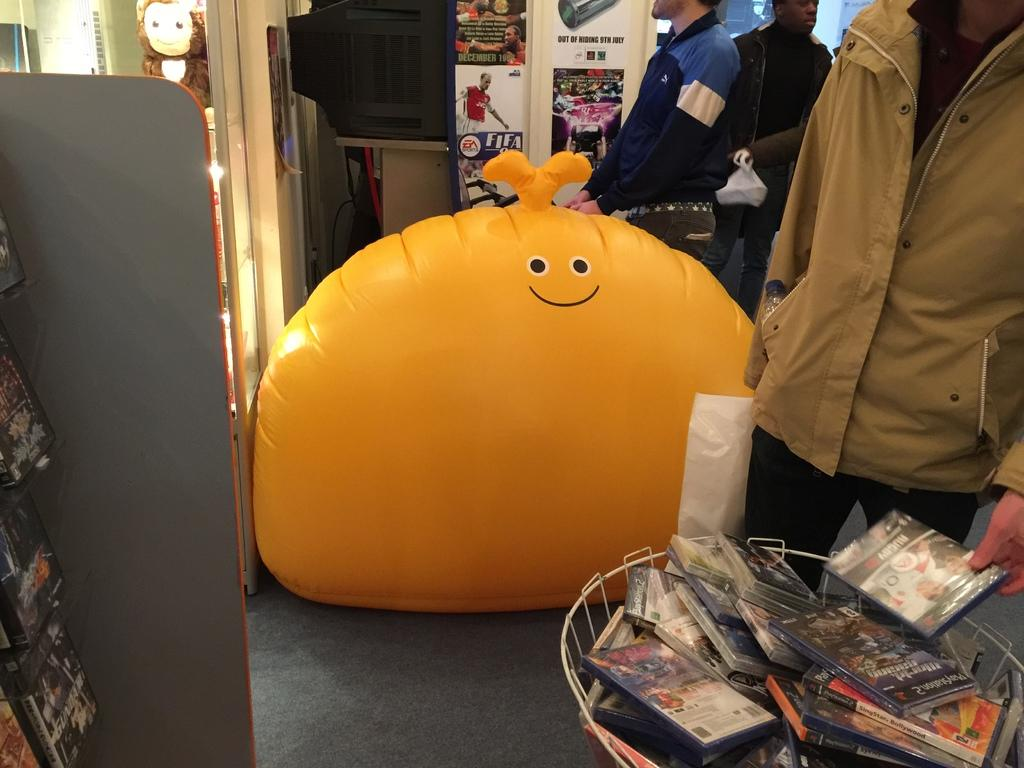<image>
Provide a brief description of the given image. Giant orange bean balloon in front of a FIFA poster. 